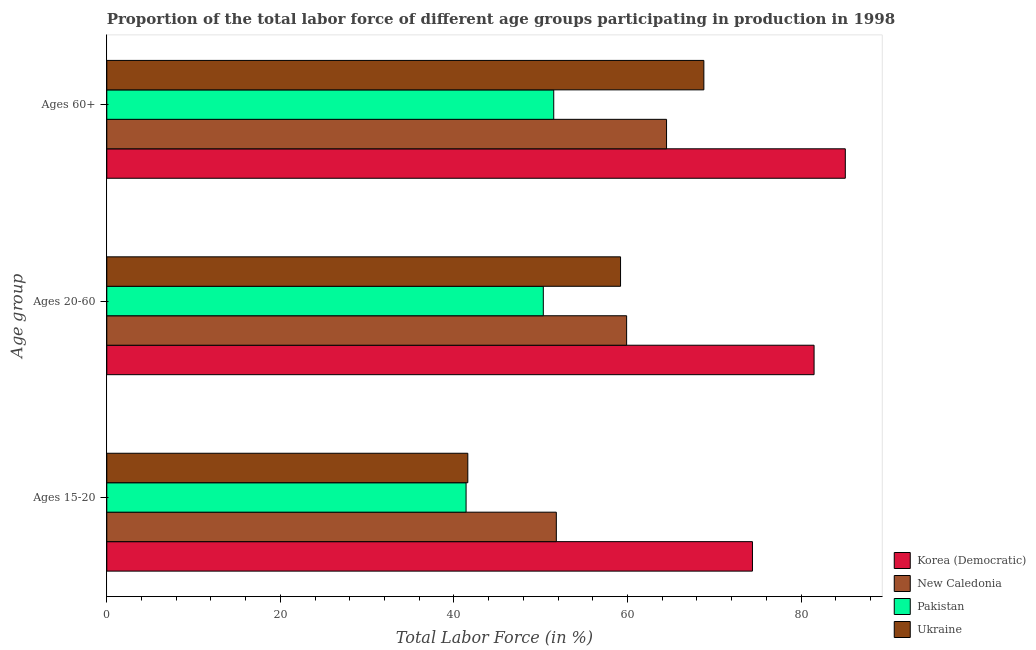How many different coloured bars are there?
Give a very brief answer. 4. How many groups of bars are there?
Provide a succinct answer. 3. How many bars are there on the 2nd tick from the top?
Offer a terse response. 4. How many bars are there on the 1st tick from the bottom?
Give a very brief answer. 4. What is the label of the 2nd group of bars from the top?
Offer a very short reply. Ages 20-60. What is the percentage of labor force within the age group 20-60 in New Caledonia?
Provide a succinct answer. 59.9. Across all countries, what is the maximum percentage of labor force above age 60?
Give a very brief answer. 85.1. Across all countries, what is the minimum percentage of labor force within the age group 15-20?
Provide a succinct answer. 41.4. In which country was the percentage of labor force within the age group 15-20 maximum?
Keep it short and to the point. Korea (Democratic). What is the total percentage of labor force within the age group 15-20 in the graph?
Ensure brevity in your answer.  209.2. What is the difference between the percentage of labor force within the age group 15-20 in Pakistan and that in Ukraine?
Give a very brief answer. -0.2. What is the difference between the percentage of labor force within the age group 20-60 in Pakistan and the percentage of labor force above age 60 in Ukraine?
Provide a short and direct response. -18.5. What is the average percentage of labor force within the age group 15-20 per country?
Make the answer very short. 52.3. What is the difference between the percentage of labor force above age 60 and percentage of labor force within the age group 20-60 in Korea (Democratic)?
Provide a succinct answer. 3.6. What is the ratio of the percentage of labor force above age 60 in Pakistan to that in Ukraine?
Provide a succinct answer. 0.75. Is the percentage of labor force within the age group 15-20 in Ukraine less than that in New Caledonia?
Keep it short and to the point. Yes. What is the difference between the highest and the second highest percentage of labor force within the age group 15-20?
Ensure brevity in your answer.  22.6. What is the difference between the highest and the lowest percentage of labor force within the age group 20-60?
Your answer should be very brief. 31.2. In how many countries, is the percentage of labor force within the age group 15-20 greater than the average percentage of labor force within the age group 15-20 taken over all countries?
Give a very brief answer. 1. What does the 1st bar from the top in Ages 20-60 represents?
Keep it short and to the point. Ukraine. What does the 4th bar from the bottom in Ages 15-20 represents?
Your answer should be compact. Ukraine. What is the difference between two consecutive major ticks on the X-axis?
Keep it short and to the point. 20. Are the values on the major ticks of X-axis written in scientific E-notation?
Offer a very short reply. No. Does the graph contain any zero values?
Your answer should be very brief. No. Does the graph contain grids?
Your answer should be very brief. No. What is the title of the graph?
Offer a very short reply. Proportion of the total labor force of different age groups participating in production in 1998. Does "Vietnam" appear as one of the legend labels in the graph?
Make the answer very short. No. What is the label or title of the X-axis?
Your response must be concise. Total Labor Force (in %). What is the label or title of the Y-axis?
Your answer should be compact. Age group. What is the Total Labor Force (in %) in Korea (Democratic) in Ages 15-20?
Offer a terse response. 74.4. What is the Total Labor Force (in %) of New Caledonia in Ages 15-20?
Provide a short and direct response. 51.8. What is the Total Labor Force (in %) in Pakistan in Ages 15-20?
Your response must be concise. 41.4. What is the Total Labor Force (in %) of Ukraine in Ages 15-20?
Keep it short and to the point. 41.6. What is the Total Labor Force (in %) of Korea (Democratic) in Ages 20-60?
Provide a short and direct response. 81.5. What is the Total Labor Force (in %) in New Caledonia in Ages 20-60?
Provide a short and direct response. 59.9. What is the Total Labor Force (in %) of Pakistan in Ages 20-60?
Give a very brief answer. 50.3. What is the Total Labor Force (in %) of Ukraine in Ages 20-60?
Your response must be concise. 59.2. What is the Total Labor Force (in %) of Korea (Democratic) in Ages 60+?
Offer a terse response. 85.1. What is the Total Labor Force (in %) in New Caledonia in Ages 60+?
Offer a very short reply. 64.5. What is the Total Labor Force (in %) of Pakistan in Ages 60+?
Your answer should be compact. 51.5. What is the Total Labor Force (in %) in Ukraine in Ages 60+?
Give a very brief answer. 68.8. Across all Age group, what is the maximum Total Labor Force (in %) in Korea (Democratic)?
Your answer should be very brief. 85.1. Across all Age group, what is the maximum Total Labor Force (in %) of New Caledonia?
Ensure brevity in your answer.  64.5. Across all Age group, what is the maximum Total Labor Force (in %) of Pakistan?
Offer a very short reply. 51.5. Across all Age group, what is the maximum Total Labor Force (in %) in Ukraine?
Ensure brevity in your answer.  68.8. Across all Age group, what is the minimum Total Labor Force (in %) of Korea (Democratic)?
Make the answer very short. 74.4. Across all Age group, what is the minimum Total Labor Force (in %) in New Caledonia?
Make the answer very short. 51.8. Across all Age group, what is the minimum Total Labor Force (in %) of Pakistan?
Your answer should be compact. 41.4. Across all Age group, what is the minimum Total Labor Force (in %) in Ukraine?
Offer a very short reply. 41.6. What is the total Total Labor Force (in %) in Korea (Democratic) in the graph?
Your answer should be very brief. 241. What is the total Total Labor Force (in %) of New Caledonia in the graph?
Your response must be concise. 176.2. What is the total Total Labor Force (in %) of Pakistan in the graph?
Your answer should be very brief. 143.2. What is the total Total Labor Force (in %) of Ukraine in the graph?
Your answer should be compact. 169.6. What is the difference between the Total Labor Force (in %) in New Caledonia in Ages 15-20 and that in Ages 20-60?
Offer a terse response. -8.1. What is the difference between the Total Labor Force (in %) of Pakistan in Ages 15-20 and that in Ages 20-60?
Offer a terse response. -8.9. What is the difference between the Total Labor Force (in %) in Ukraine in Ages 15-20 and that in Ages 20-60?
Offer a terse response. -17.6. What is the difference between the Total Labor Force (in %) of New Caledonia in Ages 15-20 and that in Ages 60+?
Ensure brevity in your answer.  -12.7. What is the difference between the Total Labor Force (in %) of Pakistan in Ages 15-20 and that in Ages 60+?
Offer a terse response. -10.1. What is the difference between the Total Labor Force (in %) in Ukraine in Ages 15-20 and that in Ages 60+?
Offer a terse response. -27.2. What is the difference between the Total Labor Force (in %) in Pakistan in Ages 20-60 and that in Ages 60+?
Give a very brief answer. -1.2. What is the difference between the Total Labor Force (in %) of Ukraine in Ages 20-60 and that in Ages 60+?
Your answer should be compact. -9.6. What is the difference between the Total Labor Force (in %) in Korea (Democratic) in Ages 15-20 and the Total Labor Force (in %) in Pakistan in Ages 20-60?
Keep it short and to the point. 24.1. What is the difference between the Total Labor Force (in %) in New Caledonia in Ages 15-20 and the Total Labor Force (in %) in Pakistan in Ages 20-60?
Keep it short and to the point. 1.5. What is the difference between the Total Labor Force (in %) in Pakistan in Ages 15-20 and the Total Labor Force (in %) in Ukraine in Ages 20-60?
Keep it short and to the point. -17.8. What is the difference between the Total Labor Force (in %) in Korea (Democratic) in Ages 15-20 and the Total Labor Force (in %) in Pakistan in Ages 60+?
Provide a succinct answer. 22.9. What is the difference between the Total Labor Force (in %) of Korea (Democratic) in Ages 15-20 and the Total Labor Force (in %) of Ukraine in Ages 60+?
Provide a succinct answer. 5.6. What is the difference between the Total Labor Force (in %) of New Caledonia in Ages 15-20 and the Total Labor Force (in %) of Pakistan in Ages 60+?
Ensure brevity in your answer.  0.3. What is the difference between the Total Labor Force (in %) in New Caledonia in Ages 15-20 and the Total Labor Force (in %) in Ukraine in Ages 60+?
Give a very brief answer. -17. What is the difference between the Total Labor Force (in %) of Pakistan in Ages 15-20 and the Total Labor Force (in %) of Ukraine in Ages 60+?
Ensure brevity in your answer.  -27.4. What is the difference between the Total Labor Force (in %) in Korea (Democratic) in Ages 20-60 and the Total Labor Force (in %) in Pakistan in Ages 60+?
Your answer should be very brief. 30. What is the difference between the Total Labor Force (in %) in New Caledonia in Ages 20-60 and the Total Labor Force (in %) in Pakistan in Ages 60+?
Offer a terse response. 8.4. What is the difference between the Total Labor Force (in %) in Pakistan in Ages 20-60 and the Total Labor Force (in %) in Ukraine in Ages 60+?
Offer a terse response. -18.5. What is the average Total Labor Force (in %) of Korea (Democratic) per Age group?
Keep it short and to the point. 80.33. What is the average Total Labor Force (in %) of New Caledonia per Age group?
Your response must be concise. 58.73. What is the average Total Labor Force (in %) in Pakistan per Age group?
Give a very brief answer. 47.73. What is the average Total Labor Force (in %) of Ukraine per Age group?
Offer a terse response. 56.53. What is the difference between the Total Labor Force (in %) of Korea (Democratic) and Total Labor Force (in %) of New Caledonia in Ages 15-20?
Your answer should be very brief. 22.6. What is the difference between the Total Labor Force (in %) of Korea (Democratic) and Total Labor Force (in %) of Pakistan in Ages 15-20?
Your answer should be compact. 33. What is the difference between the Total Labor Force (in %) in Korea (Democratic) and Total Labor Force (in %) in Ukraine in Ages 15-20?
Your response must be concise. 32.8. What is the difference between the Total Labor Force (in %) in New Caledonia and Total Labor Force (in %) in Ukraine in Ages 15-20?
Provide a succinct answer. 10.2. What is the difference between the Total Labor Force (in %) of Pakistan and Total Labor Force (in %) of Ukraine in Ages 15-20?
Offer a very short reply. -0.2. What is the difference between the Total Labor Force (in %) of Korea (Democratic) and Total Labor Force (in %) of New Caledonia in Ages 20-60?
Provide a short and direct response. 21.6. What is the difference between the Total Labor Force (in %) in Korea (Democratic) and Total Labor Force (in %) in Pakistan in Ages 20-60?
Provide a succinct answer. 31.2. What is the difference between the Total Labor Force (in %) in Korea (Democratic) and Total Labor Force (in %) in Ukraine in Ages 20-60?
Provide a succinct answer. 22.3. What is the difference between the Total Labor Force (in %) of New Caledonia and Total Labor Force (in %) of Ukraine in Ages 20-60?
Your answer should be compact. 0.7. What is the difference between the Total Labor Force (in %) of Pakistan and Total Labor Force (in %) of Ukraine in Ages 20-60?
Offer a very short reply. -8.9. What is the difference between the Total Labor Force (in %) in Korea (Democratic) and Total Labor Force (in %) in New Caledonia in Ages 60+?
Provide a succinct answer. 20.6. What is the difference between the Total Labor Force (in %) in Korea (Democratic) and Total Labor Force (in %) in Pakistan in Ages 60+?
Make the answer very short. 33.6. What is the difference between the Total Labor Force (in %) in Korea (Democratic) and Total Labor Force (in %) in Ukraine in Ages 60+?
Your answer should be very brief. 16.3. What is the difference between the Total Labor Force (in %) in Pakistan and Total Labor Force (in %) in Ukraine in Ages 60+?
Ensure brevity in your answer.  -17.3. What is the ratio of the Total Labor Force (in %) in Korea (Democratic) in Ages 15-20 to that in Ages 20-60?
Your answer should be very brief. 0.91. What is the ratio of the Total Labor Force (in %) of New Caledonia in Ages 15-20 to that in Ages 20-60?
Provide a succinct answer. 0.86. What is the ratio of the Total Labor Force (in %) in Pakistan in Ages 15-20 to that in Ages 20-60?
Your answer should be very brief. 0.82. What is the ratio of the Total Labor Force (in %) in Ukraine in Ages 15-20 to that in Ages 20-60?
Your answer should be very brief. 0.7. What is the ratio of the Total Labor Force (in %) in Korea (Democratic) in Ages 15-20 to that in Ages 60+?
Keep it short and to the point. 0.87. What is the ratio of the Total Labor Force (in %) in New Caledonia in Ages 15-20 to that in Ages 60+?
Provide a short and direct response. 0.8. What is the ratio of the Total Labor Force (in %) of Pakistan in Ages 15-20 to that in Ages 60+?
Offer a very short reply. 0.8. What is the ratio of the Total Labor Force (in %) of Ukraine in Ages 15-20 to that in Ages 60+?
Your answer should be compact. 0.6. What is the ratio of the Total Labor Force (in %) in Korea (Democratic) in Ages 20-60 to that in Ages 60+?
Ensure brevity in your answer.  0.96. What is the ratio of the Total Labor Force (in %) in New Caledonia in Ages 20-60 to that in Ages 60+?
Provide a succinct answer. 0.93. What is the ratio of the Total Labor Force (in %) in Pakistan in Ages 20-60 to that in Ages 60+?
Your answer should be compact. 0.98. What is the ratio of the Total Labor Force (in %) in Ukraine in Ages 20-60 to that in Ages 60+?
Give a very brief answer. 0.86. What is the difference between the highest and the second highest Total Labor Force (in %) of Korea (Democratic)?
Your answer should be very brief. 3.6. What is the difference between the highest and the second highest Total Labor Force (in %) in New Caledonia?
Your answer should be very brief. 4.6. What is the difference between the highest and the second highest Total Labor Force (in %) in Ukraine?
Give a very brief answer. 9.6. What is the difference between the highest and the lowest Total Labor Force (in %) of New Caledonia?
Your response must be concise. 12.7. What is the difference between the highest and the lowest Total Labor Force (in %) of Ukraine?
Ensure brevity in your answer.  27.2. 